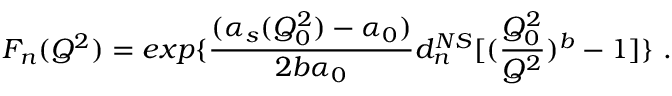Convert formula to latex. <formula><loc_0><loc_0><loc_500><loc_500>F _ { n } ( Q ^ { 2 } ) = e x p \{ { \frac { ( \alpha _ { s } ( Q _ { 0 } ^ { 2 } ) - \alpha _ { 0 } ) } { 2 b \alpha _ { 0 } } } d _ { n } ^ { N S } [ ( { \frac { Q _ { 0 } ^ { 2 } } { Q ^ { 2 } } } ) ^ { b } - 1 ] \} .</formula> 